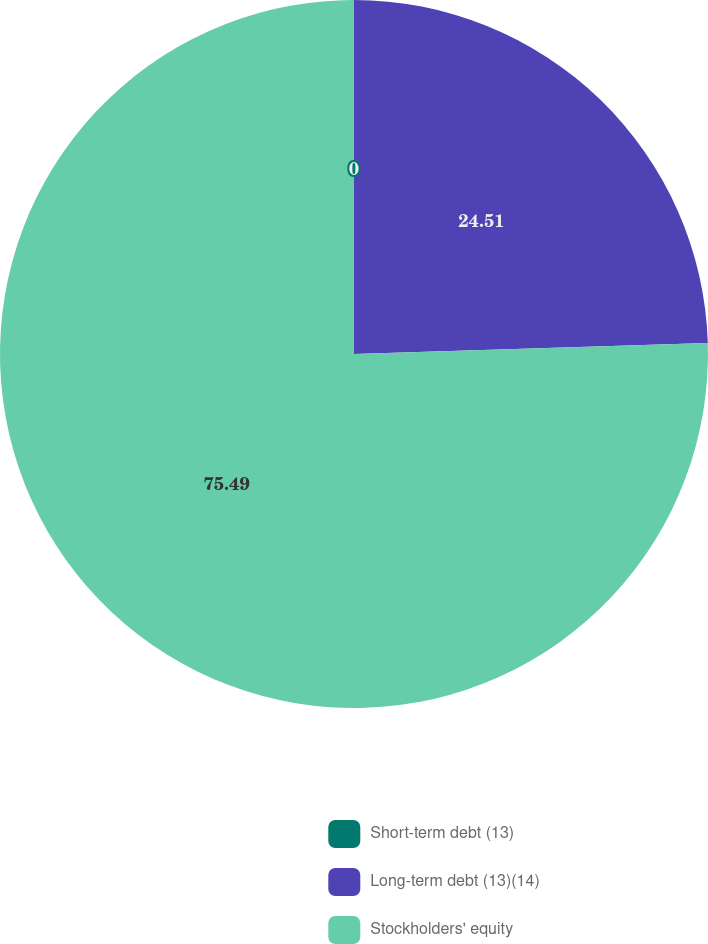Convert chart to OTSL. <chart><loc_0><loc_0><loc_500><loc_500><pie_chart><fcel>Short-term debt (13)<fcel>Long-term debt (13)(14)<fcel>Stockholders' equity<nl><fcel>0.0%<fcel>24.51%<fcel>75.49%<nl></chart> 